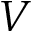<formula> <loc_0><loc_0><loc_500><loc_500>V</formula> 